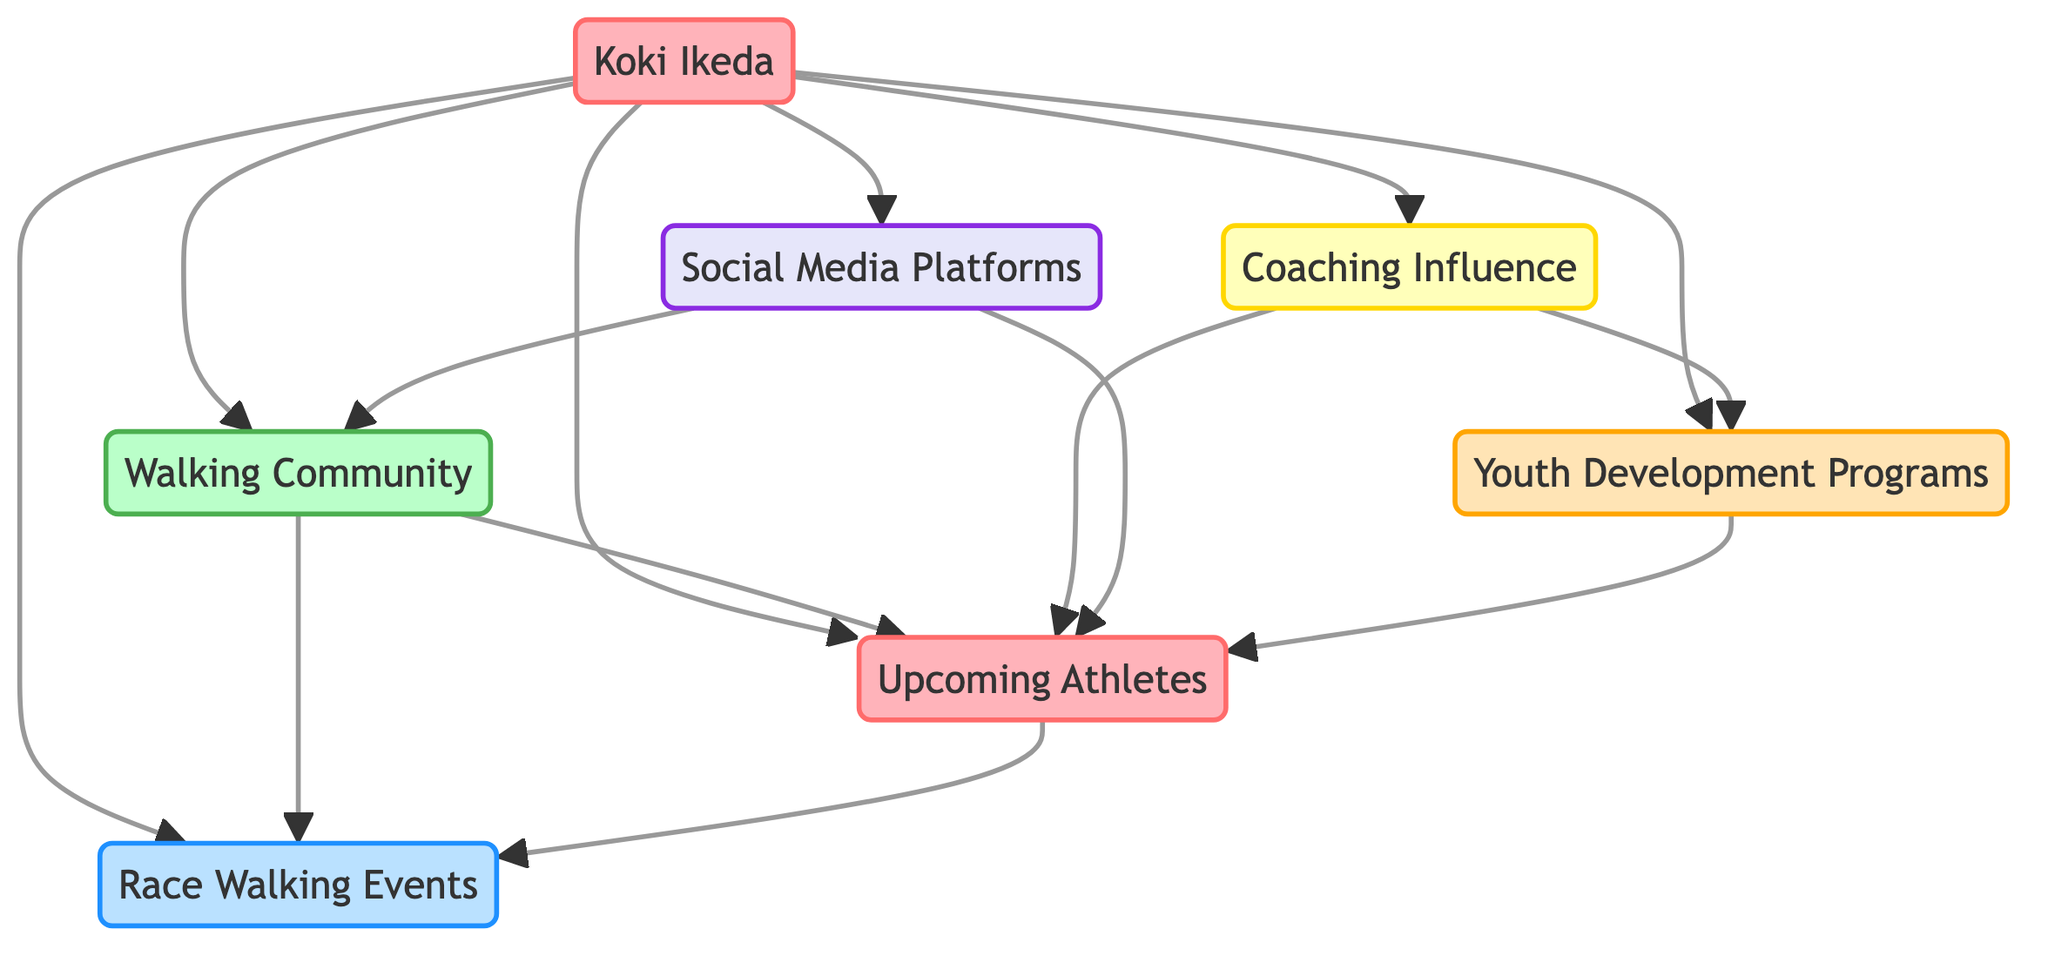What is the main influence of Koki Ikeda? Koki Ikeda influences the Walking Community, Upcoming Athletes, Race Walking Events, Coaching Influence, Social Media Platforms, and Youth Development Programs as shown by the outgoing arrows from the Koki Ikeda node connecting to these nodes.
Answer: Walking Community, Upcoming Athletes, Race Walking Events, Coaching Influence, Social Media Platforms, Youth Development Programs How many athletes are shown in the diagram? The diagram displays Koki Ikeda and Upcoming Athletes as separate nodes labeled as athletes. Therefore, counting these nodes gives a total of two athletes.
Answer: 2 What connects the Walking Community to Upcoming Athletes? There is a direct link from the Walking Community to Upcoming Athletes, indicating that the influence flows from the community towards the upcoming athletes, suggesting they are inspired by the community's enthusiasm.
Answer: Direct link Which program influences Upcoming Athletes directly? The Youth Development Programs node has a direct connection to the Upcoming Athletes node, indicating that these programs directly influence the younger athletes' development.
Answer: Youth Development Programs What roles do Coaching Influence and Social Media Platforms play concerning Upcoming Athletes? Both nodes connect directly to Upcoming Athletes. Coaching Influence provides training techniques, while Social Media Platforms engage these athletes, suggesting that both play a significant role in their development.
Answer: Coaching Influence, Social Media Platforms How many connections are there from Koki Ikeda to other nodes? Koki Ikeda has six outgoing connections to the Walking Community, Upcoming Athletes, Race Walking Events, Coaching Influence, Social Media Platforms, and Youth Development Programs, indicating a wide influence.
Answer: 6 What is the relationship between the Walking Community and Race Walking Events? The Walking Community has a direct connection to Race Walking Events, indicating that this community participates in or supports these events, showing their integral role.
Answer: Direct connection Which node serves as a source of inspiration for upcoming athletes? The main inspiration for Upcoming Athletes comes from Koki Ikeda, as shown by the direct link connecting these two nodes.
Answer: Koki Ikeda What type of events are directly influenced by Koki Ikeda? The Race Walking Events node directly connected to Koki Ikeda indicates that he is a significant influence in these specific competitive events.
Answer: Race Walking Events 